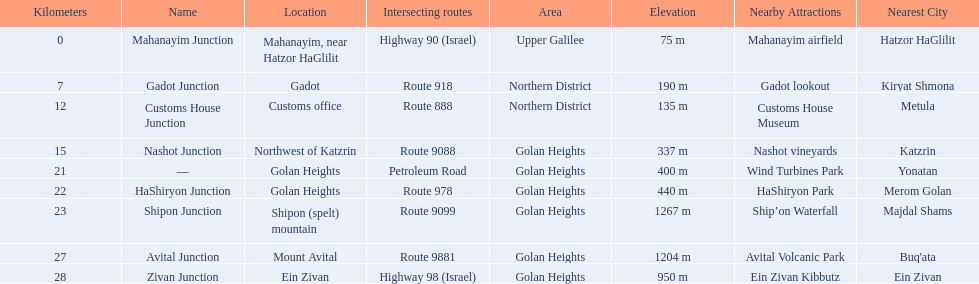Which junctions cross a route? Gadot Junction, Customs House Junction, Nashot Junction, HaShiryon Junction, Shipon Junction, Avital Junction. Which of these shares [art of its name with its locations name? Gadot Junction, Customs House Junction, Shipon Junction, Avital Junction. Which of them is not located in a locations named after a mountain? Gadot Junction, Customs House Junction. Which of these has the highest route number? Gadot Junction. 